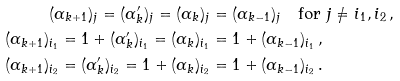<formula> <loc_0><loc_0><loc_500><loc_500>( \alpha _ { k + 1 } ) _ { j } = ( \alpha _ { k } ^ { \prime } ) _ { j } = ( \alpha _ { k } ) _ { j } & = ( \alpha _ { k - 1 } ) _ { j } \quad \text {for $j \neq i_{1}, i_{2}$} \, , \\ ( \alpha _ { k + 1 } ) _ { i _ { 1 } } = 1 + ( \alpha _ { k } ^ { \prime } ) _ { i _ { 1 } } = ( \alpha _ { k } ) _ { i _ { 1 } } & = 1 + ( \alpha _ { k - 1 } ) _ { i _ { 1 } } \, , \\ ( \alpha _ { k + 1 } ) _ { i _ { 2 } } = ( \alpha _ { k } ^ { \prime } ) _ { i _ { 2 } } = 1 + ( \alpha _ { k } ) _ { i _ { 2 } } & = 1 + ( \alpha _ { k - 1 } ) _ { i _ { 2 } } \, .</formula> 